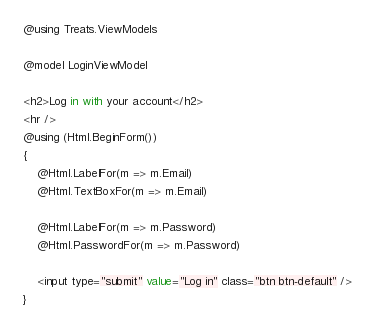<code> <loc_0><loc_0><loc_500><loc_500><_C#_>@using Treats.ViewModels

@model LoginViewModel

<h2>Log in with your account</h2>
<hr />
@using (Html.BeginForm())
{
    @Html.LabelFor(m => m.Email)
    @Html.TextBoxFor(m => m.Email)

    @Html.LabelFor(m => m.Password)
    @Html.PasswordFor(m => m.Password)

    <input type="submit" value="Log in" class="btn btn-default" />
}</code> 